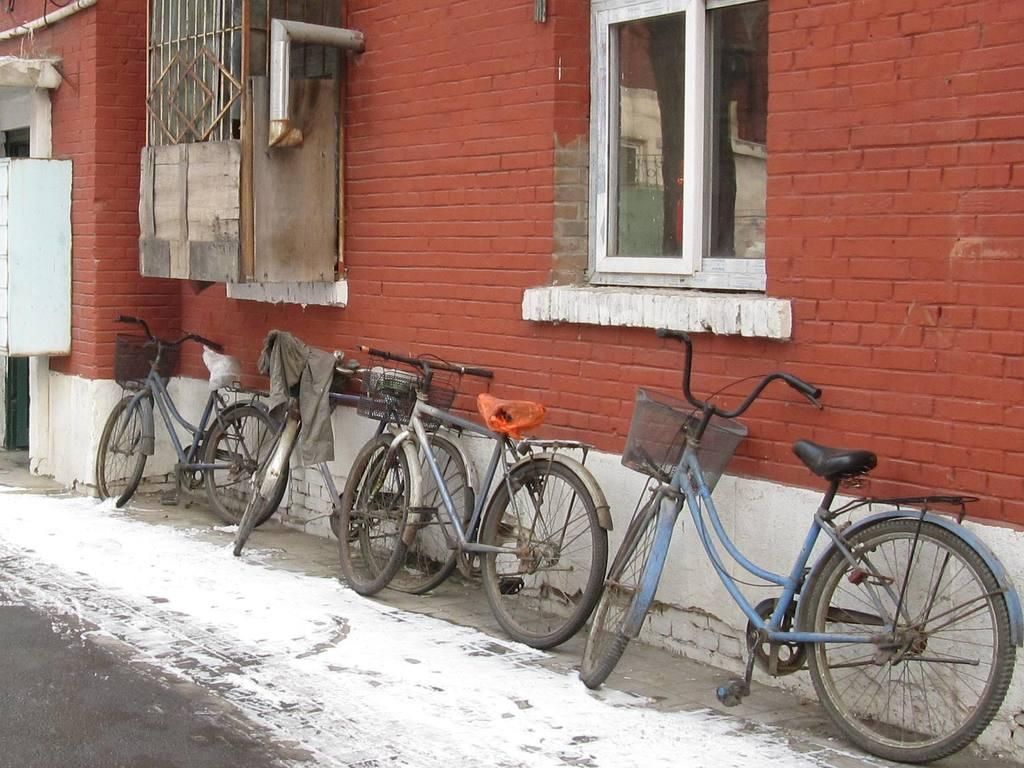What type of structure is present in the image? There is a building in the image. What features can be seen on the building? The building has a window and a door. What can be found near the building in the image? There are bicycles parked in the image. What type of plant is growing through the iron bars of the window in the image? There is no plant growing through the iron bars of the window in the image, nor is there any iron mentioned. 